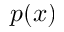<formula> <loc_0><loc_0><loc_500><loc_500>p ( x )</formula> 